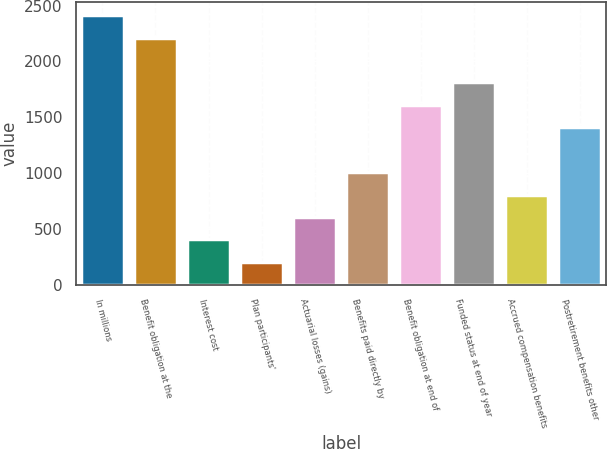<chart> <loc_0><loc_0><loc_500><loc_500><bar_chart><fcel>In millions<fcel>Benefit obligation at the<fcel>Interest cost<fcel>Plan participants'<fcel>Actuarial losses (gains)<fcel>Benefits paid directly by<fcel>Benefit obligation at end of<fcel>Funded status at end of year<fcel>Accrued compensation benefits<fcel>Postretirement benefits other<nl><fcel>2413.2<fcel>2212.6<fcel>407.2<fcel>206.6<fcel>607.8<fcel>1009<fcel>1610.8<fcel>1811.4<fcel>808.4<fcel>1410.2<nl></chart> 